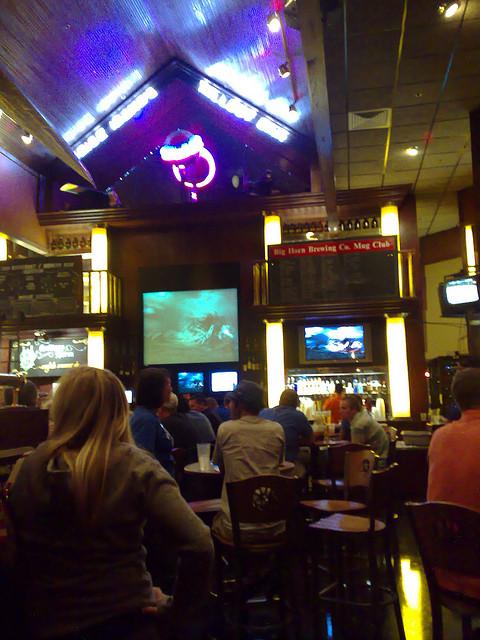Is this a bar?
Give a very brief answer. Yes. How many people in the room?
Be succinct. 12. What are they watching on TV?
Short answer required. Sports. 